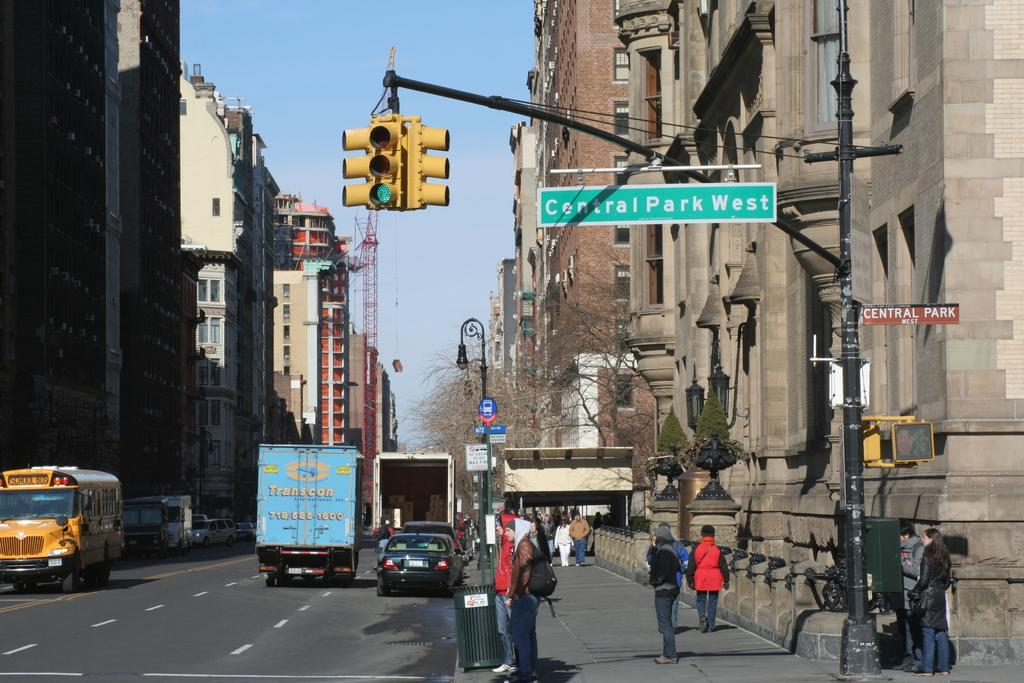<image>
Summarize the visual content of the image. The street corner for Central Park West with pedestrians and vehicles visible.. 